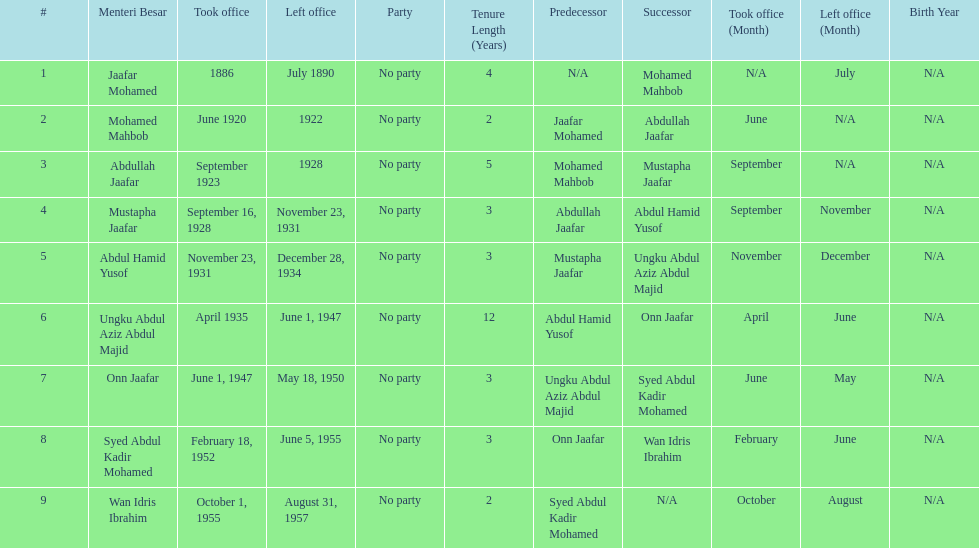Who was the first to take office? Jaafar Mohamed. 